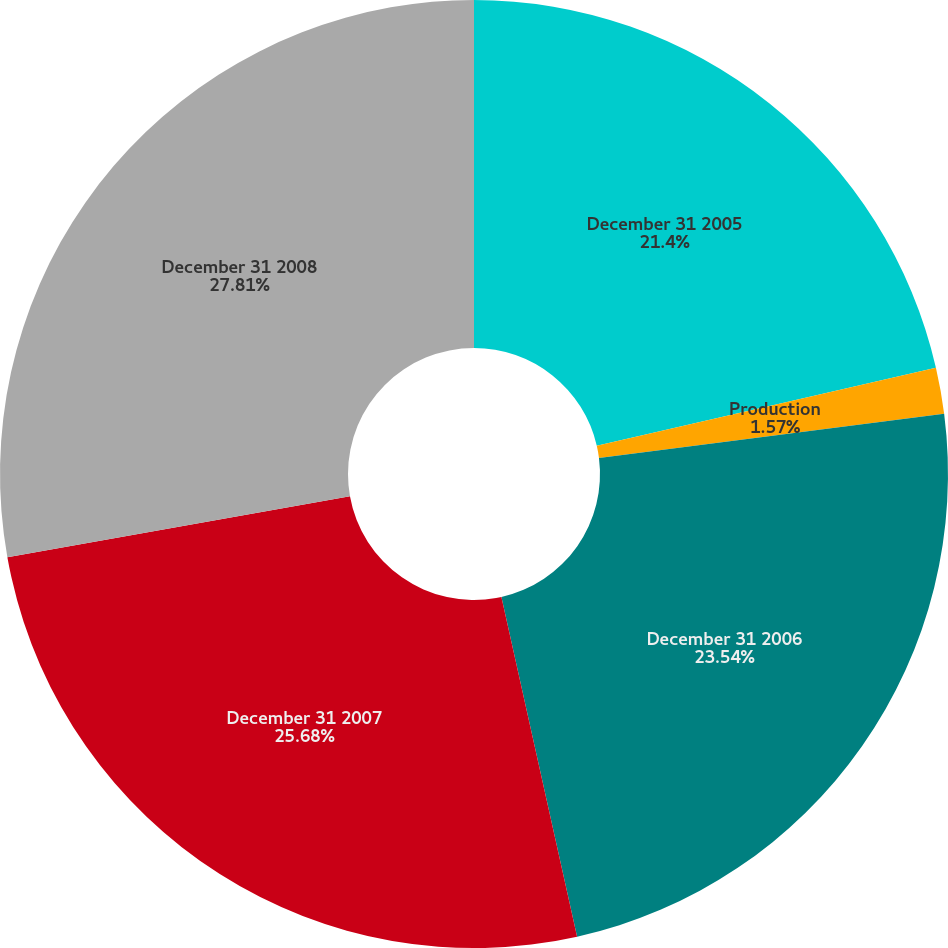Convert chart. <chart><loc_0><loc_0><loc_500><loc_500><pie_chart><fcel>December 31 2005<fcel>Production<fcel>December 31 2006<fcel>December 31 2007<fcel>December 31 2008<nl><fcel>21.4%<fcel>1.57%<fcel>23.54%<fcel>25.68%<fcel>27.81%<nl></chart> 